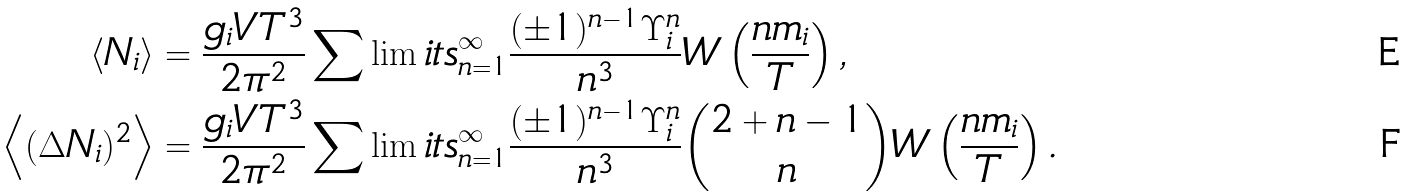Convert formula to latex. <formula><loc_0><loc_0><loc_500><loc_500>\langle N _ { i } \rangle & = \frac { g _ { i } V T ^ { 3 } } { 2 \pi ^ { 2 } } \sum \lim i t s _ { n = 1 } ^ { \infty } \frac { ( \pm 1 ) ^ { n - 1 } \Upsilon _ { i } ^ { n } } { n ^ { 3 } } { W } \left ( \frac { n m _ { i } } { T } \right ) , \\ \left \langle ( \Delta N _ { i } ) ^ { 2 } \right \rangle & = \frac { g _ { i } V T ^ { 3 } } { 2 \pi ^ { 2 } } \sum \lim i t s _ { n = 1 } ^ { \infty } \frac { ( \pm 1 ) ^ { n - 1 } \Upsilon _ { i } ^ { n } } { n ^ { 3 } } \binom { 2 + n - 1 } { n } { W } \left ( \frac { n m _ { i } } { T } \right ) .</formula> 